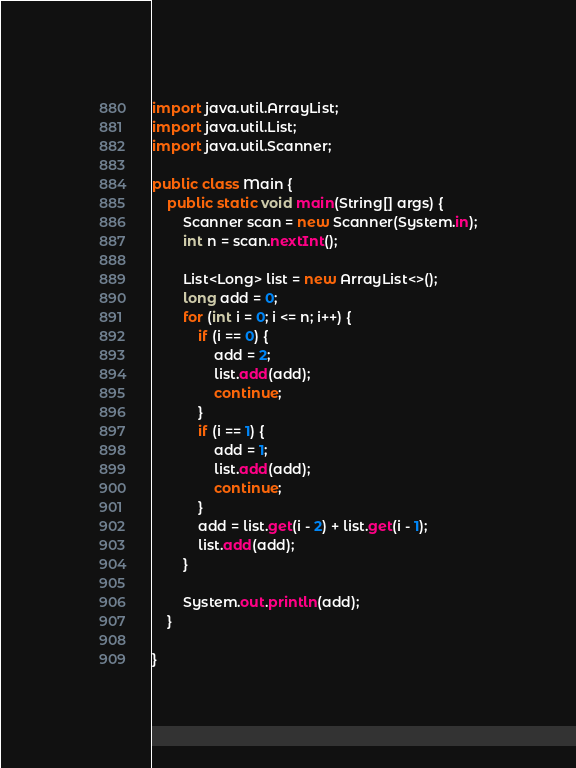Convert code to text. <code><loc_0><loc_0><loc_500><loc_500><_Java_>
import java.util.ArrayList;
import java.util.List;
import java.util.Scanner;

public class Main {
	public static void main(String[] args) {
		Scanner scan = new Scanner(System.in);
		int n = scan.nextInt();

		List<Long> list = new ArrayList<>();
		long add = 0;
		for (int i = 0; i <= n; i++) {
			if (i == 0) {
				add = 2;
				list.add(add);
				continue;
			}
			if (i == 1) {
				add = 1;
				list.add(add);
				continue;
			}
			add = list.get(i - 2) + list.get(i - 1);
			list.add(add);
		}

		System.out.println(add);
	}

}
</code> 